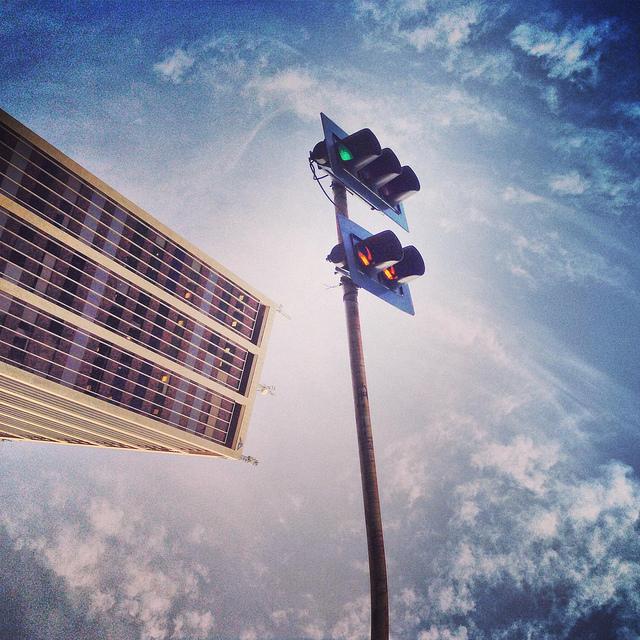How does the photo trick you into thinking the building is teetering sideways?
Give a very brief answer. Perspective. Can you see the ground?
Concise answer only. No. Do you normally see green and red lights on at the same time?
Be succinct. No. 